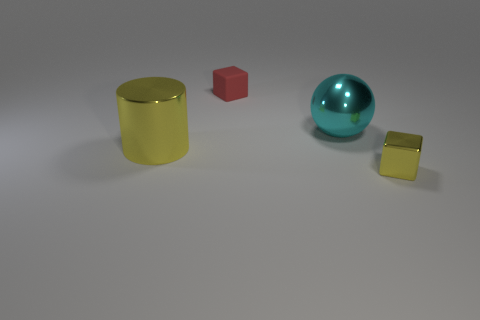Are there any other things that are made of the same material as the tiny red block?
Provide a succinct answer. No. Do the tiny yellow object and the small red rubber thing have the same shape?
Your answer should be very brief. Yes. What number of large things are blue rubber cylinders or yellow things?
Ensure brevity in your answer.  1. Is the number of small yellow metallic objects greater than the number of tiny gray shiny spheres?
Your response must be concise. Yes. What size is the other yellow thing that is made of the same material as the big yellow thing?
Ensure brevity in your answer.  Small. Does the block that is behind the tiny yellow metallic block have the same size as the cube in front of the red rubber object?
Offer a terse response. Yes. How many things are small cubes that are behind the cyan shiny thing or rubber things?
Ensure brevity in your answer.  1. Is the number of tiny red objects less than the number of cyan cylinders?
Your answer should be very brief. No. What is the shape of the yellow thing that is on the right side of the big object that is on the left side of the big thing to the right of the tiny matte block?
Provide a short and direct response. Cube. What is the shape of the thing that is the same color as the cylinder?
Give a very brief answer. Cube. 